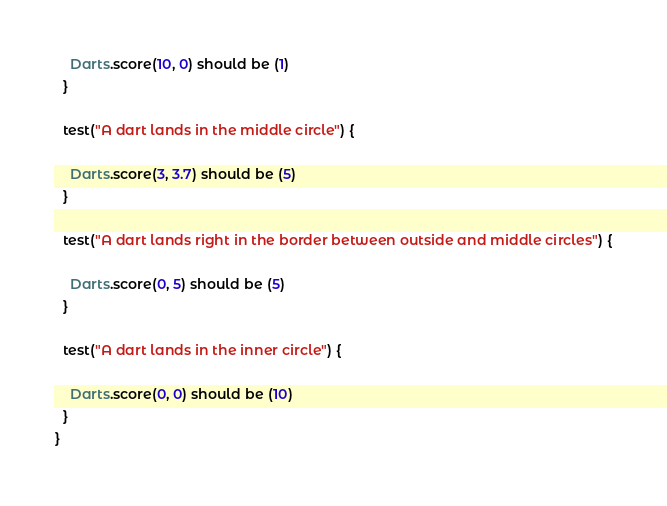<code> <loc_0><loc_0><loc_500><loc_500><_Scala_>    Darts.score(10, 0) should be (1)
  }

  test("A dart lands in the middle circle") {
    
    Darts.score(3, 3.7) should be (5)
  }

  test("A dart lands right in the border between outside and middle circles") {
    
    Darts.score(0, 5) should be (5)
  }

  test("A dart lands in the inner circle") {
    
    Darts.score(0, 0) should be (10)
  }
}</code> 